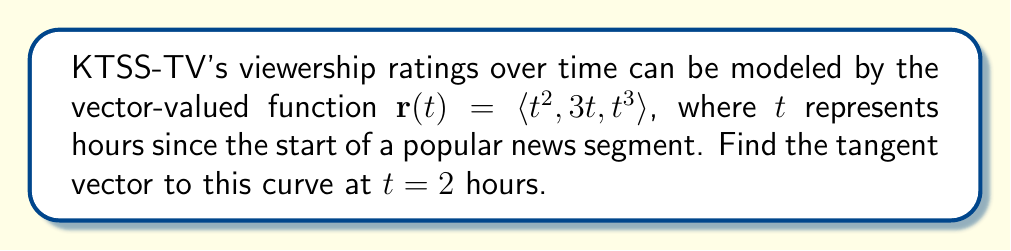Can you answer this question? To find the tangent vector to the curve at $t = 2$, we need to follow these steps:

1) The tangent vector is given by the derivative of the vector-valued function $\mathbf{r}(t)$ with respect to $t$.

2) Let's calculate $\mathbf{r}'(t)$:
   $$\mathbf{r}'(t) = \langle \frac{d}{dt}(t^2), \frac{d}{dt}(3t), \frac{d}{dt}(t^3) \rangle$$
   $$\mathbf{r}'(t) = \langle 2t, 3, 3t^2 \rangle$$

3) Now, we need to evaluate $\mathbf{r}'(t)$ at $t = 2$:
   $$\mathbf{r}'(2) = \langle 2(2), 3, 3(2)^2 \rangle$$
   $$\mathbf{r}'(2) = \langle 4, 3, 12 \rangle$$

4) This vector $\langle 4, 3, 12 \rangle$ represents the tangent vector to the curve at $t = 2$ hours.
Answer: $\langle 4, 3, 12 \rangle$ 